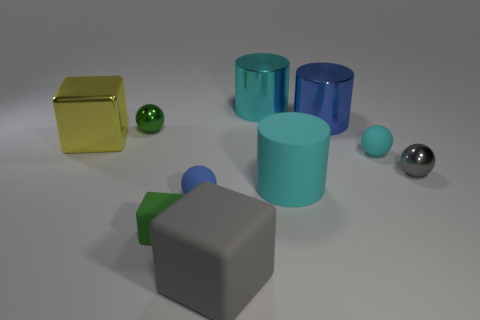Is the number of gray balls less than the number of shiny objects?
Provide a short and direct response. Yes. What is the material of the block that is the same size as the cyan matte sphere?
Offer a very short reply. Rubber. Is the number of green balls greater than the number of large rubber things?
Your response must be concise. No. What number of other things are the same color as the small rubber cube?
Give a very brief answer. 1. What number of big cyan cylinders are both behind the small green shiny object and in front of the yellow block?
Make the answer very short. 0. Are there more small spheres that are left of the large gray rubber cube than small shiny balls that are on the right side of the blue rubber ball?
Give a very brief answer. Yes. There is a small green object that is behind the yellow shiny object; what material is it?
Your answer should be compact. Metal. Do the blue matte thing and the tiny object behind the yellow shiny thing have the same shape?
Offer a very short reply. Yes. How many big objects are behind the shiny cylinder on the left side of the big shiny object that is to the right of the cyan metallic object?
Give a very brief answer. 0. There is another big matte thing that is the same shape as the green matte thing; what is its color?
Your answer should be very brief. Gray. 